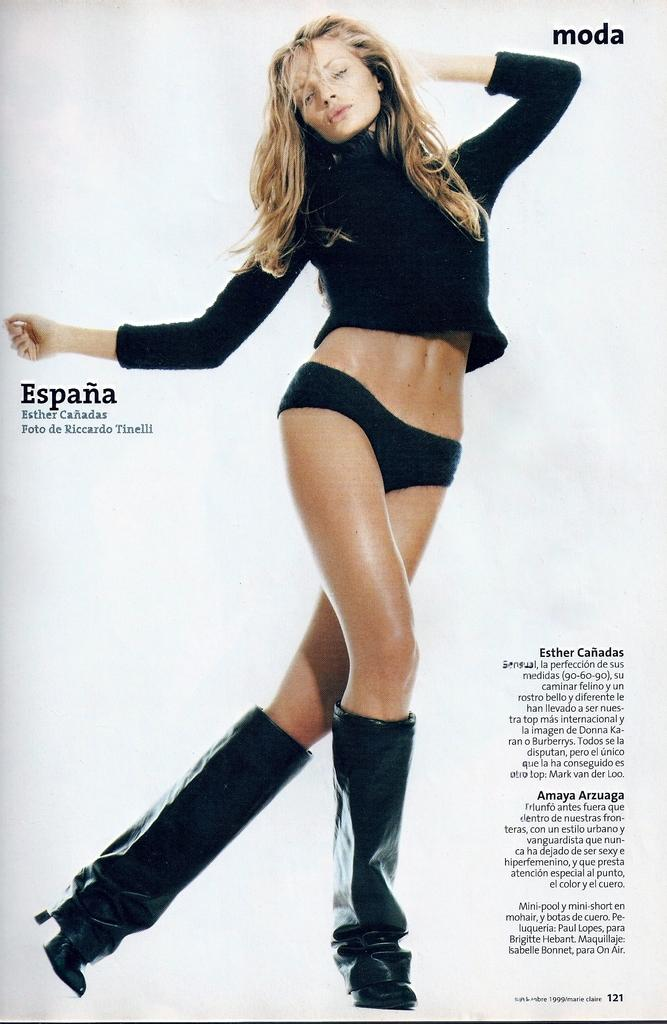What is present in the image that features an image of a woman? There is a poster in the image that contains an image of a woman. What else can be found on the poster besides the image of the woman? There is text on the poster. How many straws are floating in the water near the boat in the image? There is no boat or straws present in the image; it only features a poster with an image of a woman and text. 